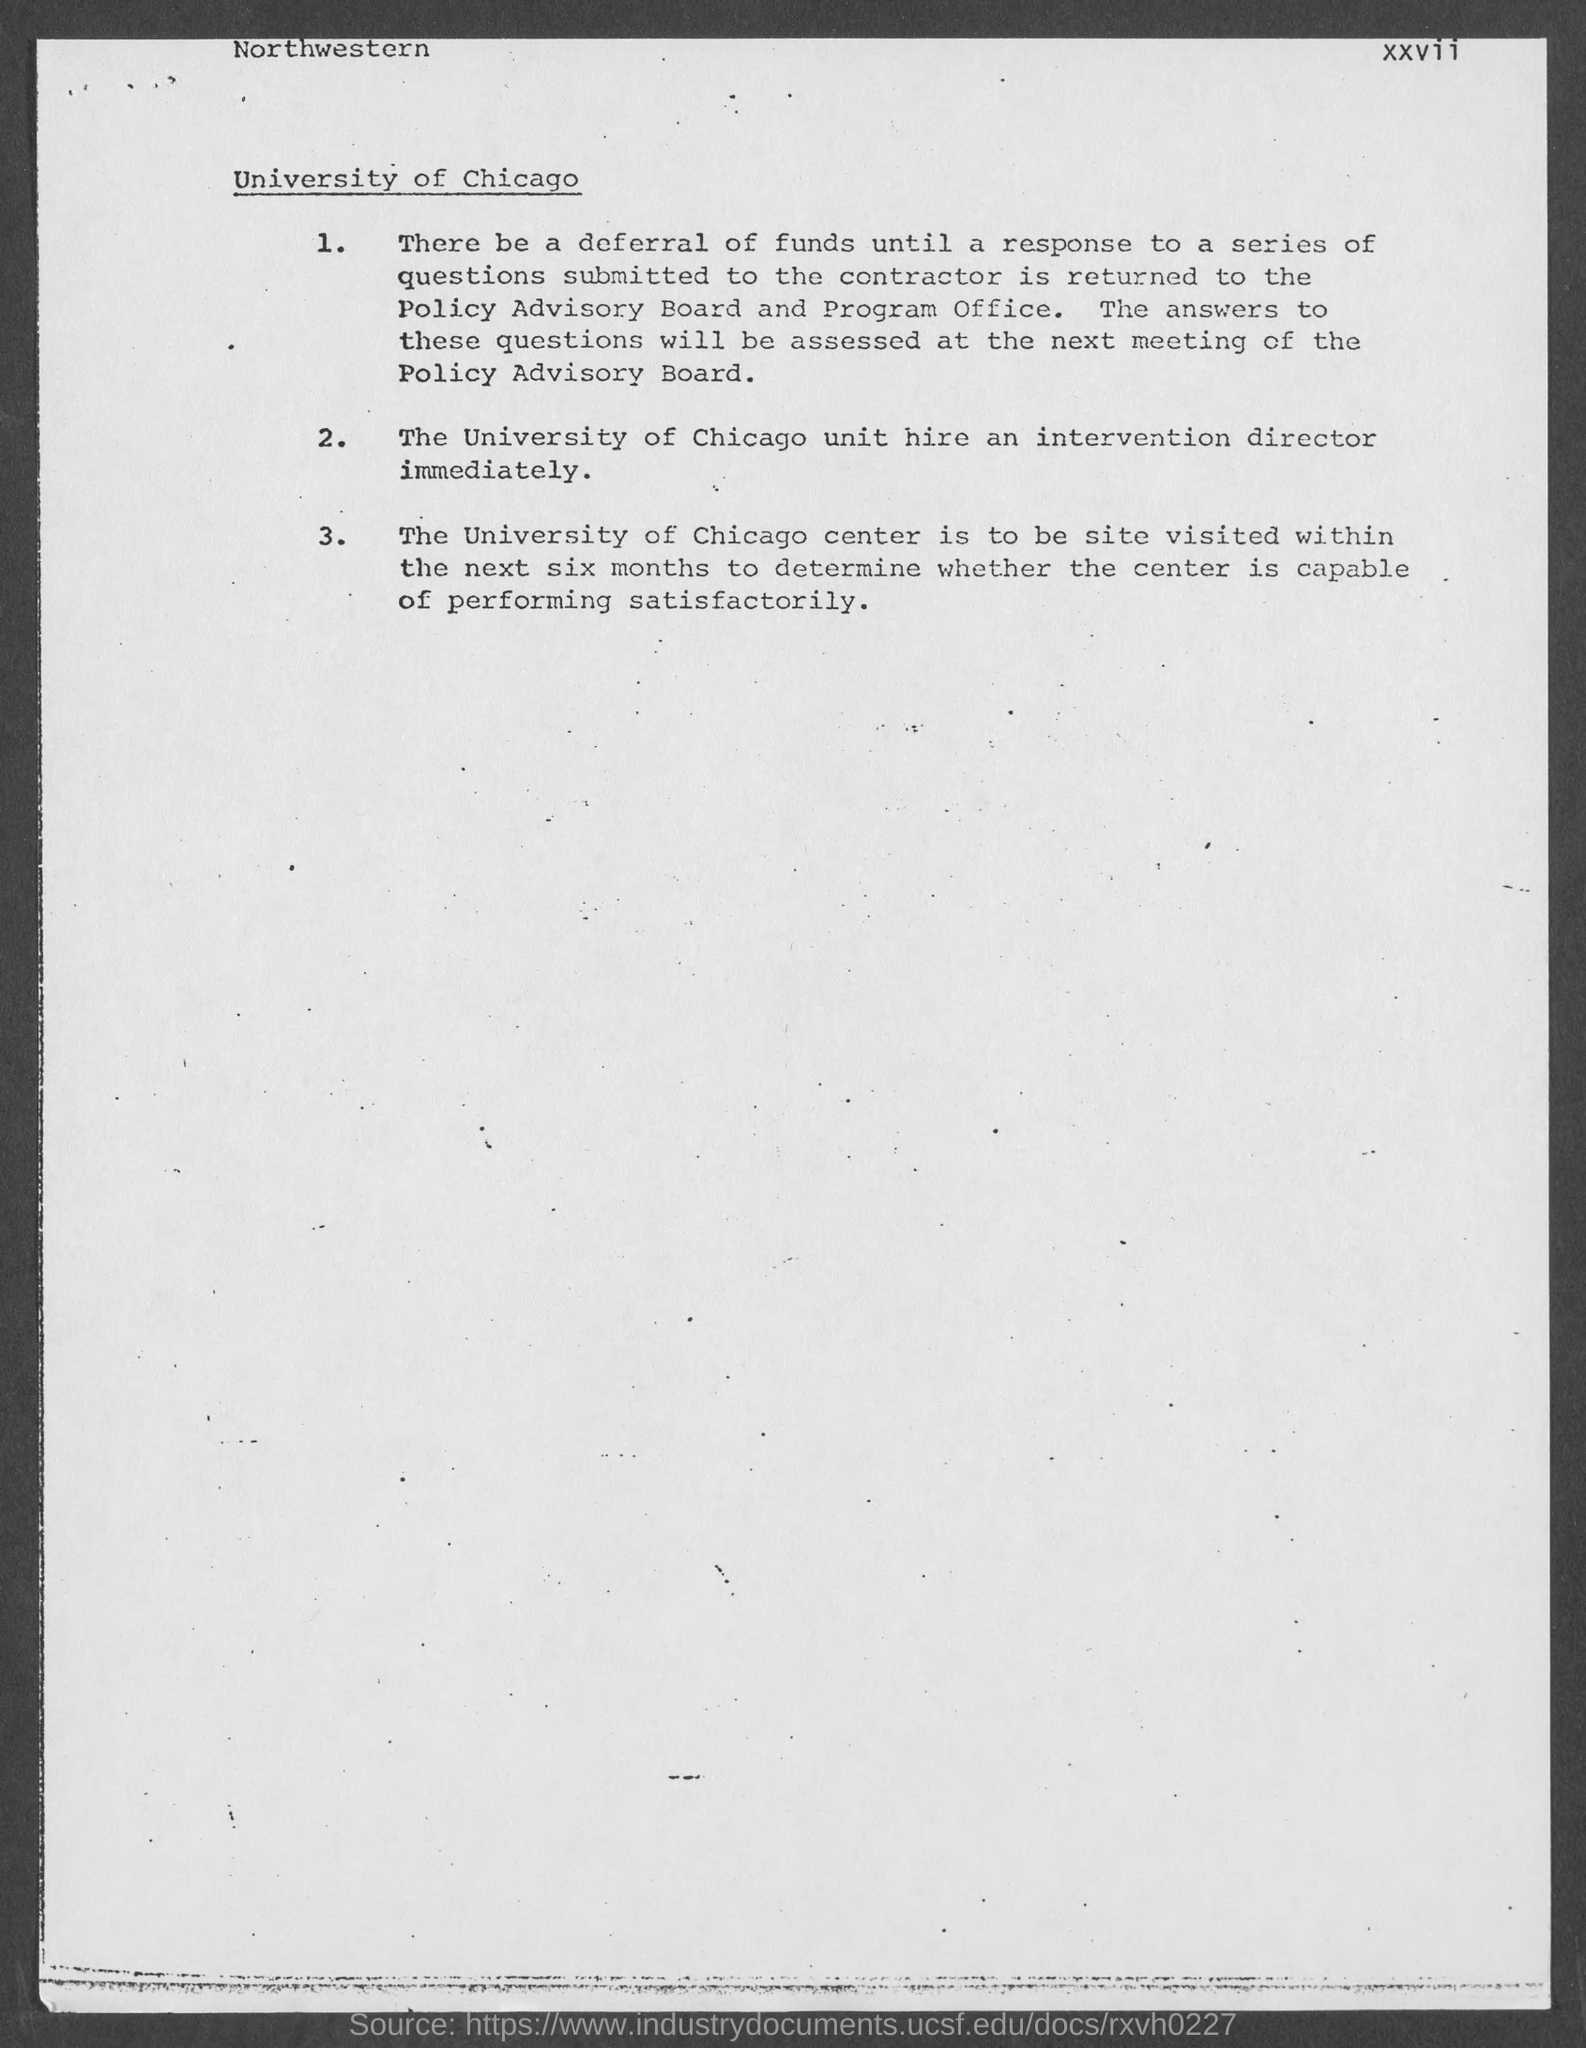Highlight a few significant elements in this photo. The title of the document is University of Chicago. The page number is xxvii.. The top-left text is "Northwestern.." in the document. 